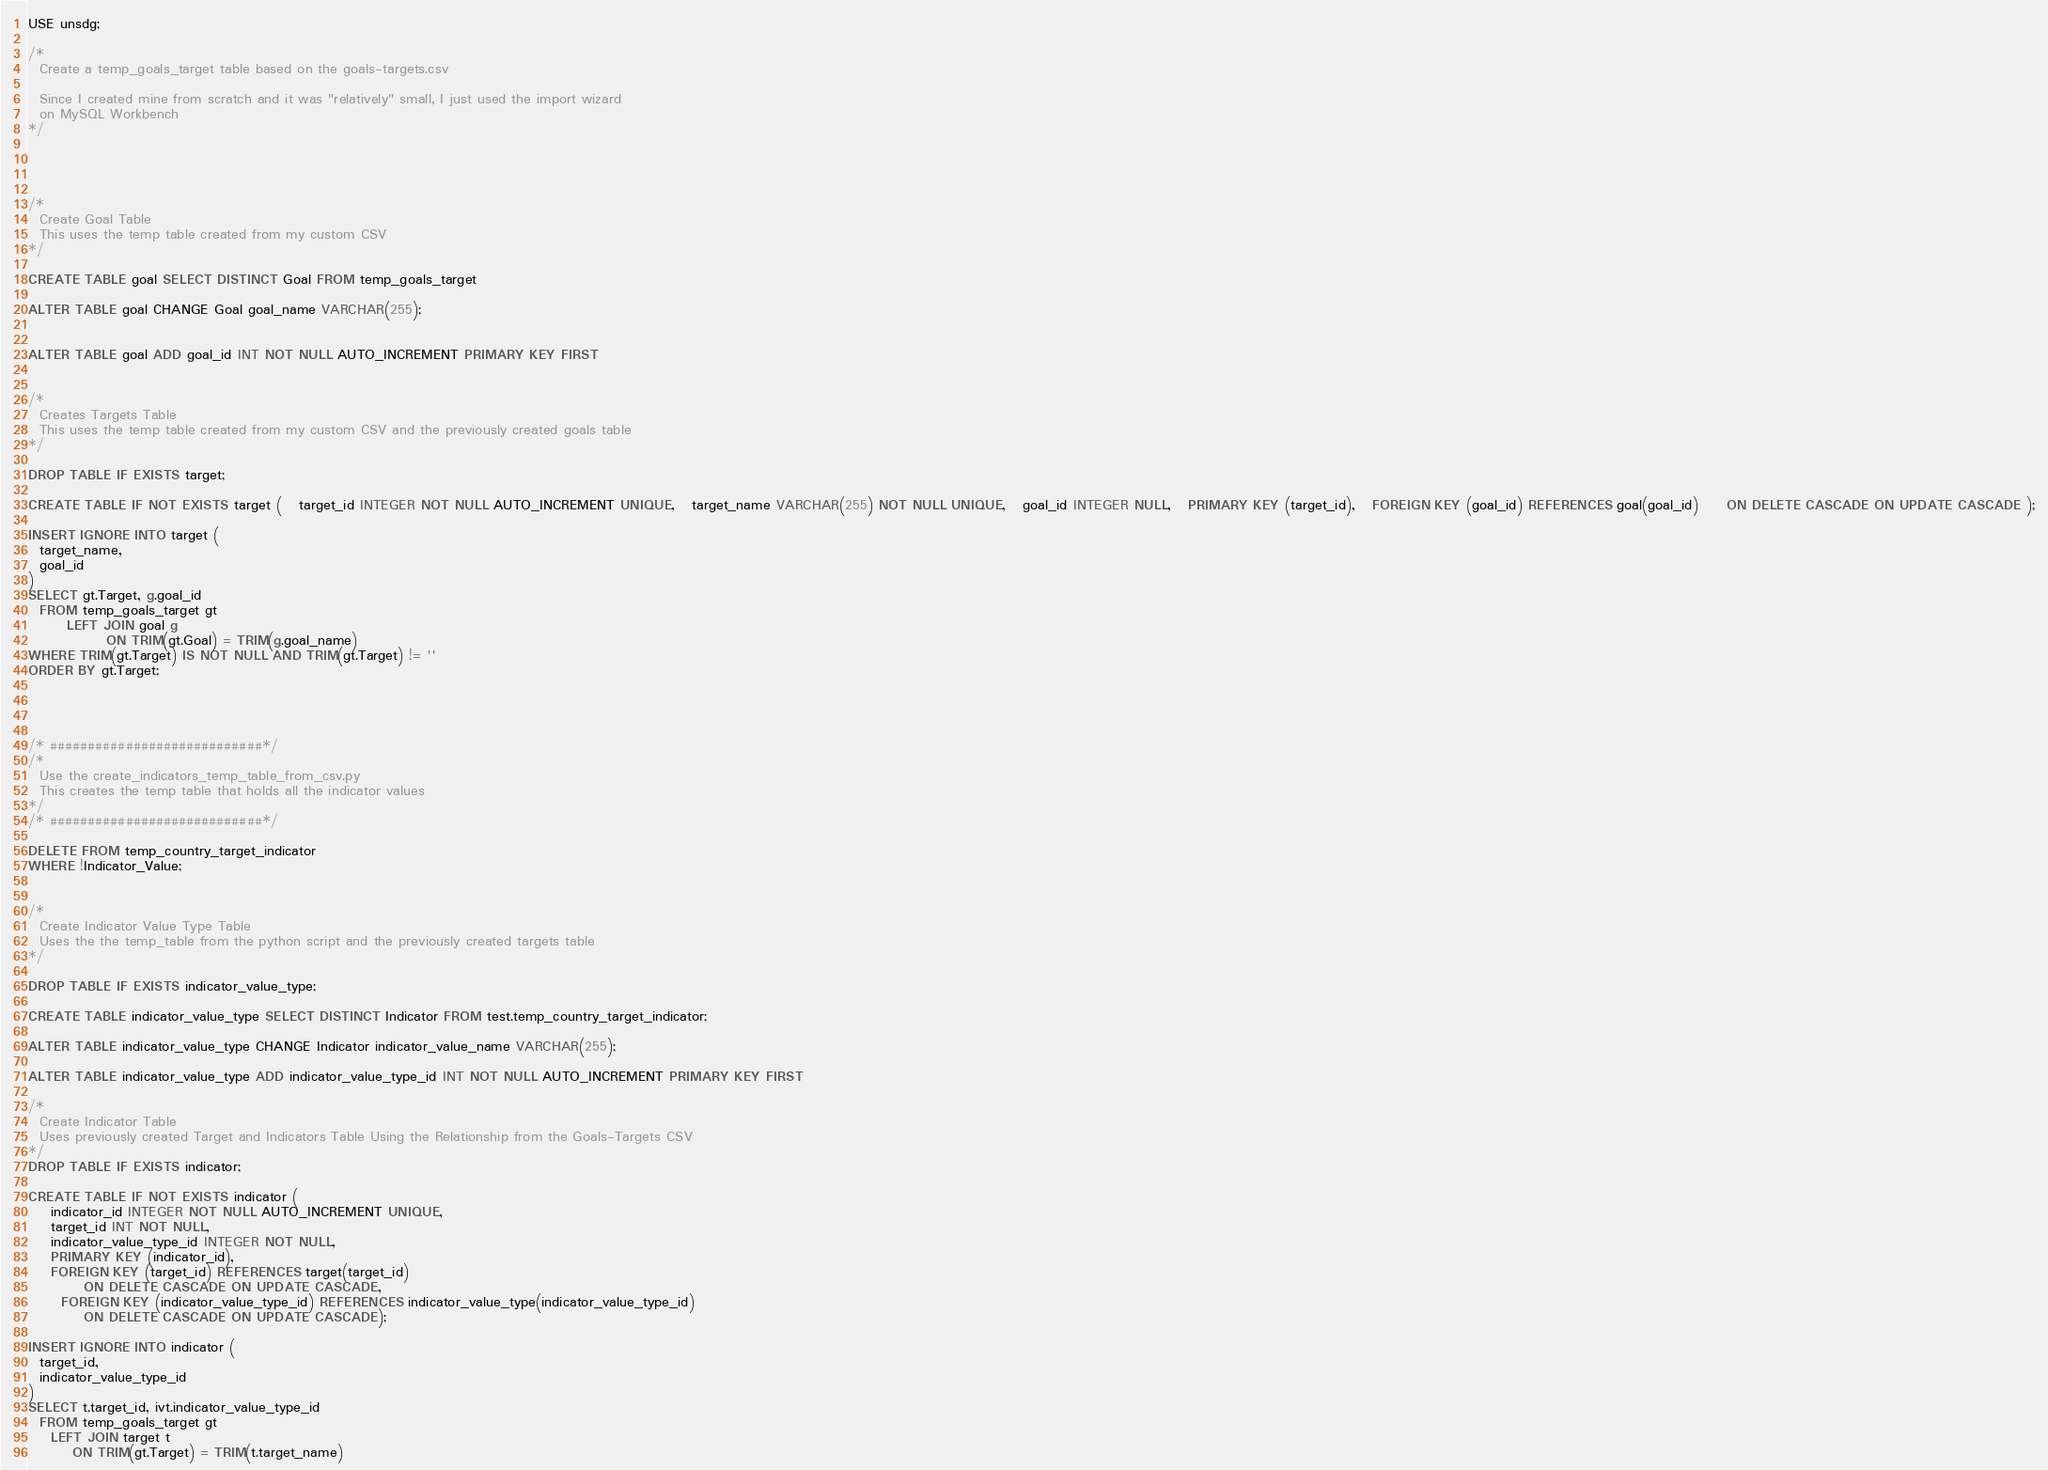<code> <loc_0><loc_0><loc_500><loc_500><_SQL_>
USE unsdg;

/*
  Create a temp_goals_target table based on the goals-targets.csv

  Since I created mine from scratch and it was "relatively" small, I just used the import wizard
  on MySQL Workbench
*/




/*
  Create Goal Table
  This uses the temp table created from my custom CSV
*/

CREATE TABLE goal SELECT DISTINCT Goal FROM temp_goals_target

ALTER TABLE goal CHANGE Goal goal_name VARCHAR(255);


ALTER TABLE goal ADD goal_id INT NOT NULL AUTO_INCREMENT PRIMARY KEY FIRST


/*
  Creates Targets Table
  This uses the temp table created from my custom CSV and the previously created goals table
*/

DROP TABLE IF EXISTS target;

CREATE TABLE IF NOT EXISTS target (   target_id INTEGER NOT NULL AUTO_INCREMENT UNIQUE,   target_name VARCHAR(255) NOT NULL UNIQUE,   goal_id INTEGER NULL,   PRIMARY KEY (target_id),   FOREIGN KEY (goal_id) REFERENCES goal(goal_id)     ON DELETE CASCADE ON UPDATE CASCADE );

INSERT IGNORE INTO target (
  target_name,
  goal_id
)
SELECT gt.Target, g.goal_id
  FROM temp_goals_target gt
       LEFT JOIN goal g
              ON TRIM(gt.Goal) = TRIM(g.goal_name)
WHERE TRIM(gt.Target) IS NOT NULL AND TRIM(gt.Target) != ''
ORDER BY gt.Target;




/* ############################*/
/* 
  Use the create_indicators_temp_table_from_csv.py 
  This creates the temp table that holds all the indicator values
*/
/* ############################*/

DELETE FROM temp_country_target_indicator
WHERE !Indicator_Value;


/*
  Create Indicator Value Type Table
  Uses the the temp_table from the python script and the previously created targets table
*/

DROP TABLE IF EXISTS indicator_value_type;

CREATE TABLE indicator_value_type SELECT DISTINCT Indicator FROM test.temp_country_target_indicator;

ALTER TABLE indicator_value_type CHANGE Indicator indicator_value_name VARCHAR(255);

ALTER TABLE indicator_value_type ADD indicator_value_type_id INT NOT NULL AUTO_INCREMENT PRIMARY KEY FIRST

/*
  Create Indicator Table 
  Uses previously created Target and Indicators Table Using the Relationship from the Goals-Targets CSV
*/
DROP TABLE IF EXISTS indicator;

CREATE TABLE IF NOT EXISTS indicator (   
	indicator_id INTEGER NOT NULL AUTO_INCREMENT UNIQUE,   
    target_id INT NOT NULL,   
    indicator_value_type_id INTEGER NOT NULL,   
    PRIMARY KEY (indicator_id),   
    FOREIGN KEY (target_id) REFERENCES target(target_id)
		  ON DELETE CASCADE ON UPDATE CASCADE,
	  FOREIGN KEY (indicator_value_type_id) REFERENCES indicator_value_type(indicator_value_type_id)
		  ON DELETE CASCADE ON UPDATE CASCADE);

INSERT IGNORE INTO indicator (
  target_id,
  indicator_value_type_id
)
SELECT t.target_id, ivt.indicator_value_type_id
  FROM temp_goals_target gt
    LEFT JOIN target t
        ON TRIM(gt.Target) = TRIM(t.target_name)</code> 